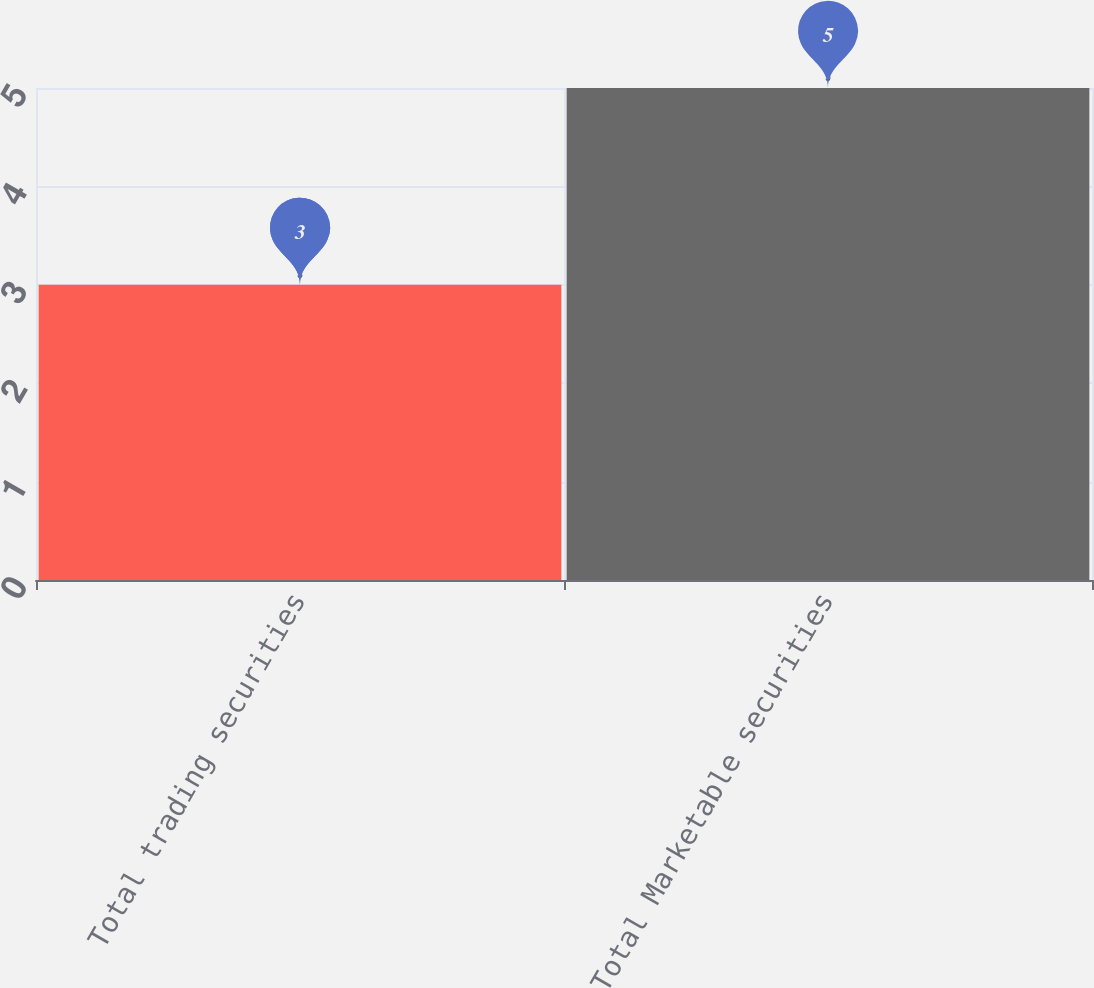<chart> <loc_0><loc_0><loc_500><loc_500><bar_chart><fcel>Total trading securities<fcel>Total Marketable securities<nl><fcel>3<fcel>5<nl></chart> 